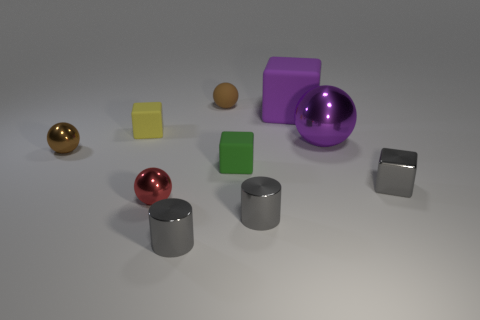Subtract 1 balls. How many balls are left? 3 Subtract all blue spheres. Subtract all purple cubes. How many spheres are left? 4 Subtract all cylinders. How many objects are left? 8 Subtract all tiny yellow things. Subtract all large purple rubber cubes. How many objects are left? 8 Add 8 gray blocks. How many gray blocks are left? 9 Add 8 brown objects. How many brown objects exist? 10 Subtract 0 yellow balls. How many objects are left? 10 